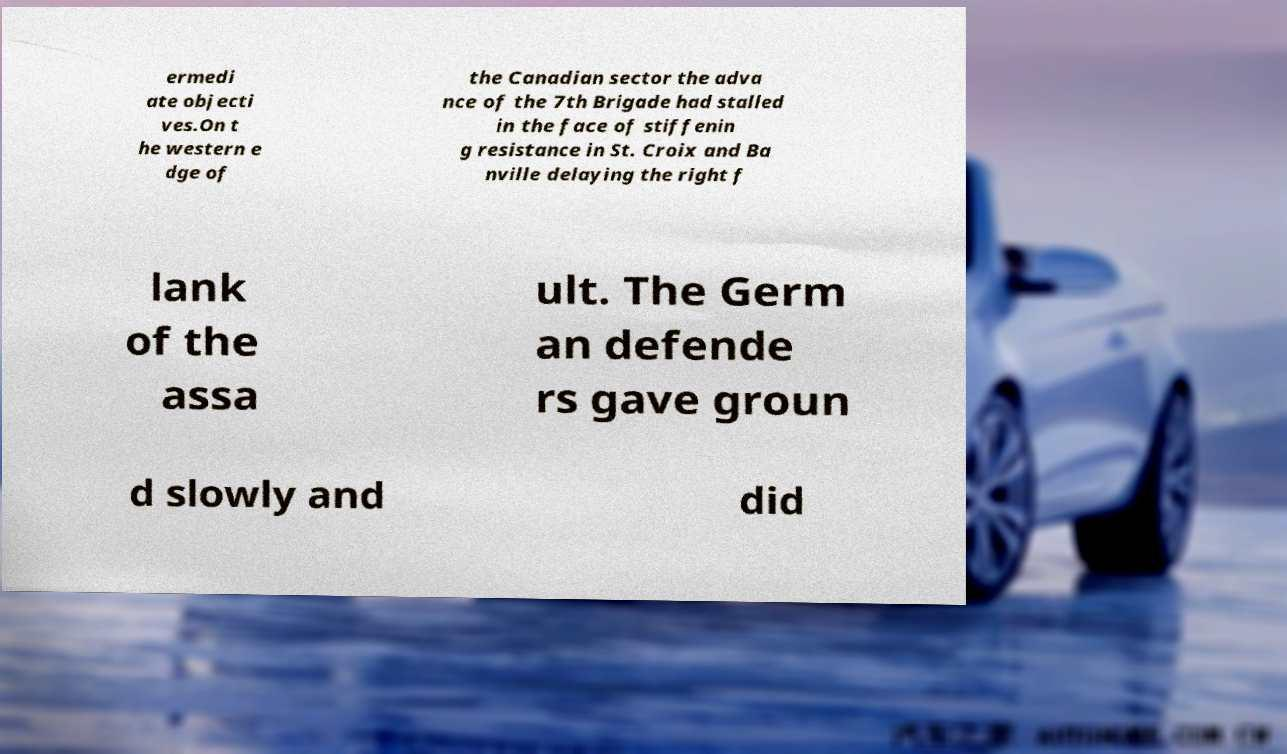Could you extract and type out the text from this image? ermedi ate objecti ves.On t he western e dge of the Canadian sector the adva nce of the 7th Brigade had stalled in the face of stiffenin g resistance in St. Croix and Ba nville delaying the right f lank of the assa ult. The Germ an defende rs gave groun d slowly and did 